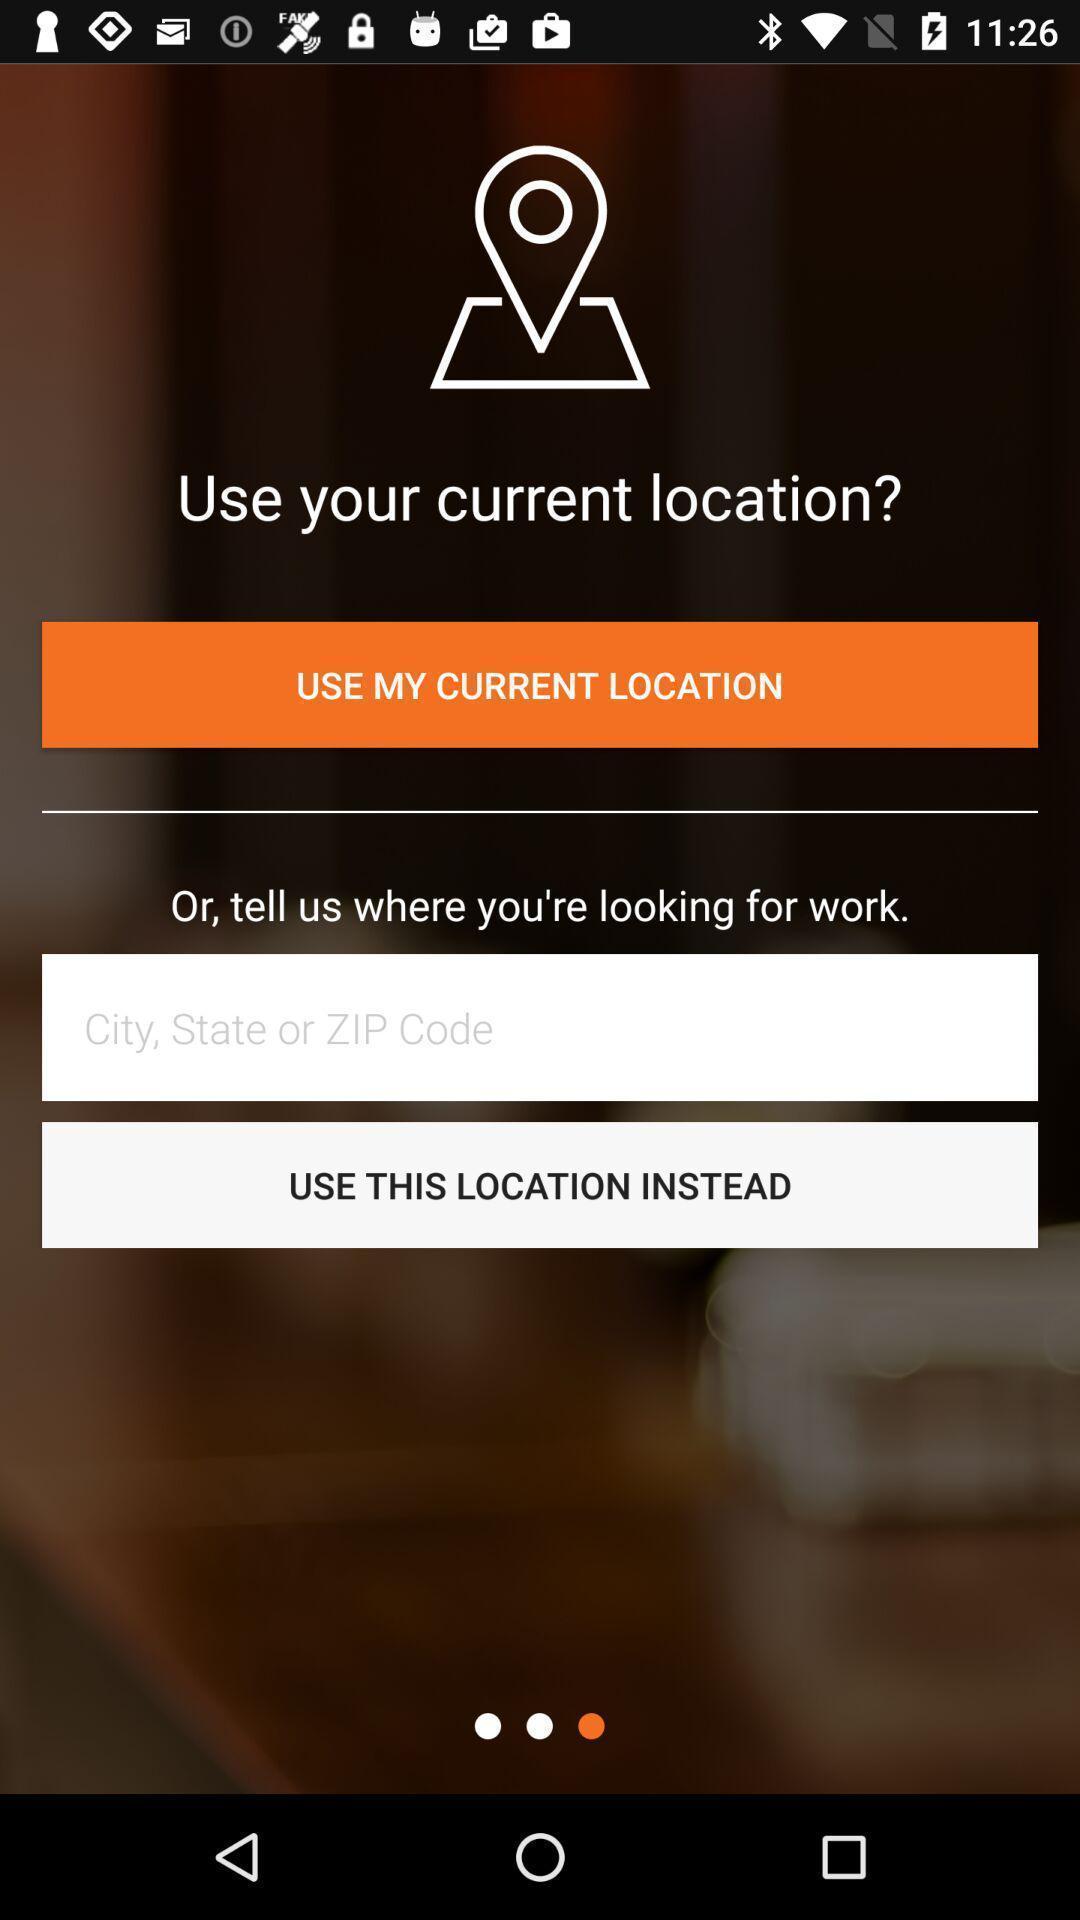Give me a narrative description of this picture. Search page for finding the location on mapping app. 